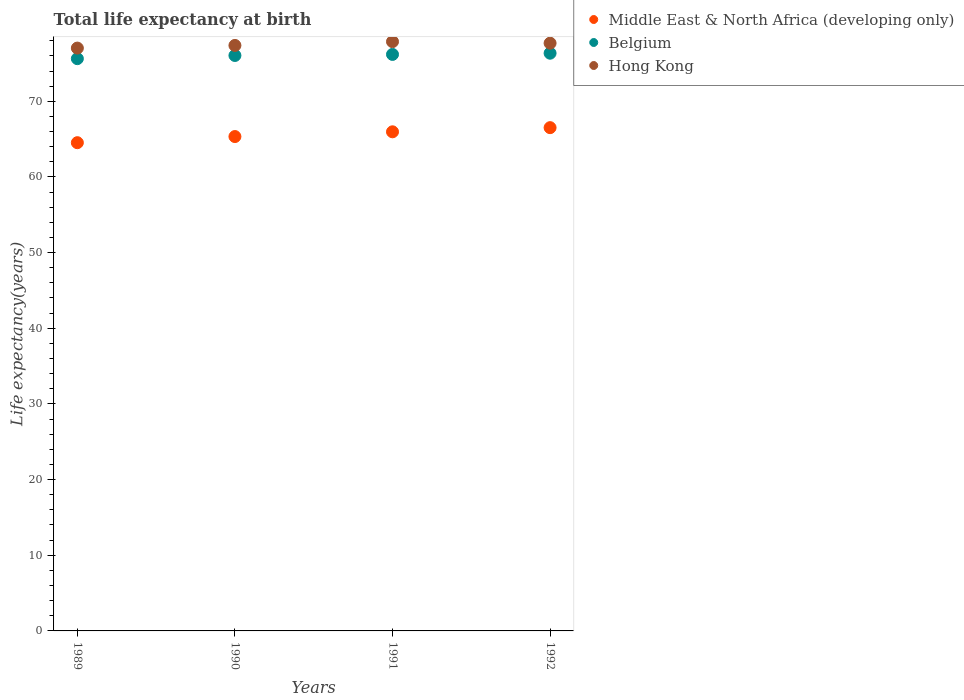What is the life expectancy at birth in in Middle East & North Africa (developing only) in 1991?
Give a very brief answer. 65.96. Across all years, what is the maximum life expectancy at birth in in Hong Kong?
Provide a succinct answer. 77.88. Across all years, what is the minimum life expectancy at birth in in Middle East & North Africa (developing only)?
Offer a very short reply. 64.53. In which year was the life expectancy at birth in in Hong Kong minimum?
Make the answer very short. 1989. What is the total life expectancy at birth in in Middle East & North Africa (developing only) in the graph?
Provide a short and direct response. 262.34. What is the difference between the life expectancy at birth in in Middle East & North Africa (developing only) in 1989 and that in 1990?
Offer a very short reply. -0.81. What is the difference between the life expectancy at birth in in Belgium in 1989 and the life expectancy at birth in in Middle East & North Africa (developing only) in 1990?
Ensure brevity in your answer.  10.3. What is the average life expectancy at birth in in Belgium per year?
Your answer should be compact. 76.06. In the year 1989, what is the difference between the life expectancy at birth in in Middle East & North Africa (developing only) and life expectancy at birth in in Hong Kong?
Provide a short and direct response. -12.5. In how many years, is the life expectancy at birth in in Belgium greater than 46 years?
Offer a terse response. 4. What is the ratio of the life expectancy at birth in in Hong Kong in 1989 to that in 1992?
Ensure brevity in your answer.  0.99. Is the difference between the life expectancy at birth in in Middle East & North Africa (developing only) in 1989 and 1990 greater than the difference between the life expectancy at birth in in Hong Kong in 1989 and 1990?
Provide a succinct answer. No. What is the difference between the highest and the second highest life expectancy at birth in in Belgium?
Give a very brief answer. 0.16. What is the difference between the highest and the lowest life expectancy at birth in in Middle East & North Africa (developing only)?
Provide a succinct answer. 1.99. Is the sum of the life expectancy at birth in in Hong Kong in 1990 and 1991 greater than the maximum life expectancy at birth in in Middle East & North Africa (developing only) across all years?
Provide a short and direct response. Yes. Is it the case that in every year, the sum of the life expectancy at birth in in Middle East & North Africa (developing only) and life expectancy at birth in in Belgium  is greater than the life expectancy at birth in in Hong Kong?
Your response must be concise. Yes. Does the life expectancy at birth in in Hong Kong monotonically increase over the years?
Provide a short and direct response. No. How many dotlines are there?
Keep it short and to the point. 3. How many years are there in the graph?
Your answer should be very brief. 4. Does the graph contain any zero values?
Provide a succinct answer. No. Where does the legend appear in the graph?
Provide a succinct answer. Top right. How many legend labels are there?
Keep it short and to the point. 3. What is the title of the graph?
Ensure brevity in your answer.  Total life expectancy at birth. Does "Tunisia" appear as one of the legend labels in the graph?
Ensure brevity in your answer.  No. What is the label or title of the X-axis?
Ensure brevity in your answer.  Years. What is the label or title of the Y-axis?
Offer a very short reply. Life expectancy(years). What is the Life expectancy(years) of Middle East & North Africa (developing only) in 1989?
Offer a very short reply. 64.53. What is the Life expectancy(years) of Belgium in 1989?
Provide a succinct answer. 75.63. What is the Life expectancy(years) in Hong Kong in 1989?
Your answer should be very brief. 77.03. What is the Life expectancy(years) of Middle East & North Africa (developing only) in 1990?
Your answer should be compact. 65.34. What is the Life expectancy(years) in Belgium in 1990?
Give a very brief answer. 76.05. What is the Life expectancy(years) of Hong Kong in 1990?
Offer a terse response. 77.38. What is the Life expectancy(years) of Middle East & North Africa (developing only) in 1991?
Your answer should be compact. 65.96. What is the Life expectancy(years) of Belgium in 1991?
Offer a very short reply. 76.19. What is the Life expectancy(years) in Hong Kong in 1991?
Offer a terse response. 77.88. What is the Life expectancy(years) of Middle East & North Africa (developing only) in 1992?
Your answer should be compact. 66.51. What is the Life expectancy(years) of Belgium in 1992?
Your answer should be very brief. 76.35. What is the Life expectancy(years) of Hong Kong in 1992?
Ensure brevity in your answer.  77.68. Across all years, what is the maximum Life expectancy(years) of Middle East & North Africa (developing only)?
Your answer should be very brief. 66.51. Across all years, what is the maximum Life expectancy(years) of Belgium?
Provide a short and direct response. 76.35. Across all years, what is the maximum Life expectancy(years) in Hong Kong?
Give a very brief answer. 77.88. Across all years, what is the minimum Life expectancy(years) in Middle East & North Africa (developing only)?
Make the answer very short. 64.53. Across all years, what is the minimum Life expectancy(years) in Belgium?
Provide a short and direct response. 75.63. Across all years, what is the minimum Life expectancy(years) in Hong Kong?
Offer a very short reply. 77.03. What is the total Life expectancy(years) of Middle East & North Africa (developing only) in the graph?
Make the answer very short. 262.34. What is the total Life expectancy(years) of Belgium in the graph?
Offer a very short reply. 304.23. What is the total Life expectancy(years) in Hong Kong in the graph?
Ensure brevity in your answer.  309.97. What is the difference between the Life expectancy(years) in Middle East & North Africa (developing only) in 1989 and that in 1990?
Offer a terse response. -0.81. What is the difference between the Life expectancy(years) of Belgium in 1989 and that in 1990?
Keep it short and to the point. -0.42. What is the difference between the Life expectancy(years) in Hong Kong in 1989 and that in 1990?
Your answer should be compact. -0.35. What is the difference between the Life expectancy(years) in Middle East & North Africa (developing only) in 1989 and that in 1991?
Your answer should be compact. -1.44. What is the difference between the Life expectancy(years) in Belgium in 1989 and that in 1991?
Provide a short and direct response. -0.56. What is the difference between the Life expectancy(years) of Hong Kong in 1989 and that in 1991?
Keep it short and to the point. -0.85. What is the difference between the Life expectancy(years) in Middle East & North Africa (developing only) in 1989 and that in 1992?
Make the answer very short. -1.99. What is the difference between the Life expectancy(years) of Belgium in 1989 and that in 1992?
Keep it short and to the point. -0.72. What is the difference between the Life expectancy(years) of Hong Kong in 1989 and that in 1992?
Make the answer very short. -0.65. What is the difference between the Life expectancy(years) in Middle East & North Africa (developing only) in 1990 and that in 1991?
Give a very brief answer. -0.63. What is the difference between the Life expectancy(years) of Belgium in 1990 and that in 1991?
Make the answer very short. -0.14. What is the difference between the Life expectancy(years) of Hong Kong in 1990 and that in 1991?
Provide a short and direct response. -0.5. What is the difference between the Life expectancy(years) of Middle East & North Africa (developing only) in 1990 and that in 1992?
Offer a terse response. -1.18. What is the difference between the Life expectancy(years) in Belgium in 1990 and that in 1992?
Your answer should be very brief. -0.3. What is the difference between the Life expectancy(years) of Hong Kong in 1990 and that in 1992?
Give a very brief answer. -0.3. What is the difference between the Life expectancy(years) in Middle East & North Africa (developing only) in 1991 and that in 1992?
Your answer should be very brief. -0.55. What is the difference between the Life expectancy(years) in Belgium in 1991 and that in 1992?
Provide a short and direct response. -0.16. What is the difference between the Life expectancy(years) in Hong Kong in 1991 and that in 1992?
Your answer should be compact. 0.2. What is the difference between the Life expectancy(years) in Middle East & North Africa (developing only) in 1989 and the Life expectancy(years) in Belgium in 1990?
Your response must be concise. -11.53. What is the difference between the Life expectancy(years) in Middle East & North Africa (developing only) in 1989 and the Life expectancy(years) in Hong Kong in 1990?
Your response must be concise. -12.85. What is the difference between the Life expectancy(years) of Belgium in 1989 and the Life expectancy(years) of Hong Kong in 1990?
Your answer should be very brief. -1.75. What is the difference between the Life expectancy(years) in Middle East & North Africa (developing only) in 1989 and the Life expectancy(years) in Belgium in 1991?
Your answer should be very brief. -11.67. What is the difference between the Life expectancy(years) in Middle East & North Africa (developing only) in 1989 and the Life expectancy(years) in Hong Kong in 1991?
Ensure brevity in your answer.  -13.36. What is the difference between the Life expectancy(years) of Belgium in 1989 and the Life expectancy(years) of Hong Kong in 1991?
Ensure brevity in your answer.  -2.25. What is the difference between the Life expectancy(years) in Middle East & North Africa (developing only) in 1989 and the Life expectancy(years) in Belgium in 1992?
Your answer should be very brief. -11.82. What is the difference between the Life expectancy(years) of Middle East & North Africa (developing only) in 1989 and the Life expectancy(years) of Hong Kong in 1992?
Ensure brevity in your answer.  -13.15. What is the difference between the Life expectancy(years) of Belgium in 1989 and the Life expectancy(years) of Hong Kong in 1992?
Offer a very short reply. -2.05. What is the difference between the Life expectancy(years) of Middle East & North Africa (developing only) in 1990 and the Life expectancy(years) of Belgium in 1991?
Ensure brevity in your answer.  -10.86. What is the difference between the Life expectancy(years) of Middle East & North Africa (developing only) in 1990 and the Life expectancy(years) of Hong Kong in 1991?
Offer a very short reply. -12.55. What is the difference between the Life expectancy(years) of Belgium in 1990 and the Life expectancy(years) of Hong Kong in 1991?
Make the answer very short. -1.83. What is the difference between the Life expectancy(years) in Middle East & North Africa (developing only) in 1990 and the Life expectancy(years) in Belgium in 1992?
Your answer should be very brief. -11.01. What is the difference between the Life expectancy(years) in Middle East & North Africa (developing only) in 1990 and the Life expectancy(years) in Hong Kong in 1992?
Ensure brevity in your answer.  -12.34. What is the difference between the Life expectancy(years) of Belgium in 1990 and the Life expectancy(years) of Hong Kong in 1992?
Make the answer very short. -1.63. What is the difference between the Life expectancy(years) of Middle East & North Africa (developing only) in 1991 and the Life expectancy(years) of Belgium in 1992?
Provide a short and direct response. -10.39. What is the difference between the Life expectancy(years) in Middle East & North Africa (developing only) in 1991 and the Life expectancy(years) in Hong Kong in 1992?
Your answer should be compact. -11.71. What is the difference between the Life expectancy(years) of Belgium in 1991 and the Life expectancy(years) of Hong Kong in 1992?
Give a very brief answer. -1.49. What is the average Life expectancy(years) of Middle East & North Africa (developing only) per year?
Ensure brevity in your answer.  65.59. What is the average Life expectancy(years) of Belgium per year?
Offer a terse response. 76.06. What is the average Life expectancy(years) in Hong Kong per year?
Offer a terse response. 77.49. In the year 1989, what is the difference between the Life expectancy(years) in Middle East & North Africa (developing only) and Life expectancy(years) in Belgium?
Offer a very short reply. -11.11. In the year 1989, what is the difference between the Life expectancy(years) of Middle East & North Africa (developing only) and Life expectancy(years) of Hong Kong?
Your answer should be very brief. -12.5. In the year 1989, what is the difference between the Life expectancy(years) of Belgium and Life expectancy(years) of Hong Kong?
Keep it short and to the point. -1.4. In the year 1990, what is the difference between the Life expectancy(years) of Middle East & North Africa (developing only) and Life expectancy(years) of Belgium?
Your response must be concise. -10.71. In the year 1990, what is the difference between the Life expectancy(years) in Middle East & North Africa (developing only) and Life expectancy(years) in Hong Kong?
Provide a short and direct response. -12.04. In the year 1990, what is the difference between the Life expectancy(years) in Belgium and Life expectancy(years) in Hong Kong?
Your answer should be very brief. -1.33. In the year 1991, what is the difference between the Life expectancy(years) in Middle East & North Africa (developing only) and Life expectancy(years) in Belgium?
Keep it short and to the point. -10.23. In the year 1991, what is the difference between the Life expectancy(years) of Middle East & North Africa (developing only) and Life expectancy(years) of Hong Kong?
Keep it short and to the point. -11.92. In the year 1991, what is the difference between the Life expectancy(years) of Belgium and Life expectancy(years) of Hong Kong?
Your answer should be compact. -1.69. In the year 1992, what is the difference between the Life expectancy(years) in Middle East & North Africa (developing only) and Life expectancy(years) in Belgium?
Make the answer very short. -9.84. In the year 1992, what is the difference between the Life expectancy(years) of Middle East & North Africa (developing only) and Life expectancy(years) of Hong Kong?
Give a very brief answer. -11.16. In the year 1992, what is the difference between the Life expectancy(years) in Belgium and Life expectancy(years) in Hong Kong?
Your answer should be compact. -1.33. What is the ratio of the Life expectancy(years) in Middle East & North Africa (developing only) in 1989 to that in 1990?
Your answer should be compact. 0.99. What is the ratio of the Life expectancy(years) in Belgium in 1989 to that in 1990?
Your answer should be compact. 0.99. What is the ratio of the Life expectancy(years) of Hong Kong in 1989 to that in 1990?
Keep it short and to the point. 1. What is the ratio of the Life expectancy(years) of Middle East & North Africa (developing only) in 1989 to that in 1991?
Your answer should be very brief. 0.98. What is the ratio of the Life expectancy(years) of Hong Kong in 1989 to that in 1991?
Provide a short and direct response. 0.99. What is the ratio of the Life expectancy(years) in Middle East & North Africa (developing only) in 1989 to that in 1992?
Your answer should be very brief. 0.97. What is the ratio of the Life expectancy(years) of Belgium in 1989 to that in 1992?
Provide a short and direct response. 0.99. What is the ratio of the Life expectancy(years) of Hong Kong in 1989 to that in 1992?
Ensure brevity in your answer.  0.99. What is the ratio of the Life expectancy(years) in Belgium in 1990 to that in 1991?
Ensure brevity in your answer.  1. What is the ratio of the Life expectancy(years) in Hong Kong in 1990 to that in 1991?
Your response must be concise. 0.99. What is the ratio of the Life expectancy(years) in Middle East & North Africa (developing only) in 1990 to that in 1992?
Give a very brief answer. 0.98. What is the ratio of the Life expectancy(years) in Belgium in 1990 to that in 1992?
Keep it short and to the point. 1. What is the ratio of the Life expectancy(years) in Hong Kong in 1990 to that in 1992?
Your response must be concise. 1. What is the ratio of the Life expectancy(years) in Middle East & North Africa (developing only) in 1991 to that in 1992?
Your answer should be very brief. 0.99. What is the ratio of the Life expectancy(years) in Belgium in 1991 to that in 1992?
Give a very brief answer. 1. What is the ratio of the Life expectancy(years) in Hong Kong in 1991 to that in 1992?
Provide a short and direct response. 1. What is the difference between the highest and the second highest Life expectancy(years) in Middle East & North Africa (developing only)?
Keep it short and to the point. 0.55. What is the difference between the highest and the second highest Life expectancy(years) in Belgium?
Give a very brief answer. 0.16. What is the difference between the highest and the second highest Life expectancy(years) in Hong Kong?
Make the answer very short. 0.2. What is the difference between the highest and the lowest Life expectancy(years) of Middle East & North Africa (developing only)?
Give a very brief answer. 1.99. What is the difference between the highest and the lowest Life expectancy(years) in Belgium?
Provide a short and direct response. 0.72. What is the difference between the highest and the lowest Life expectancy(years) in Hong Kong?
Your response must be concise. 0.85. 